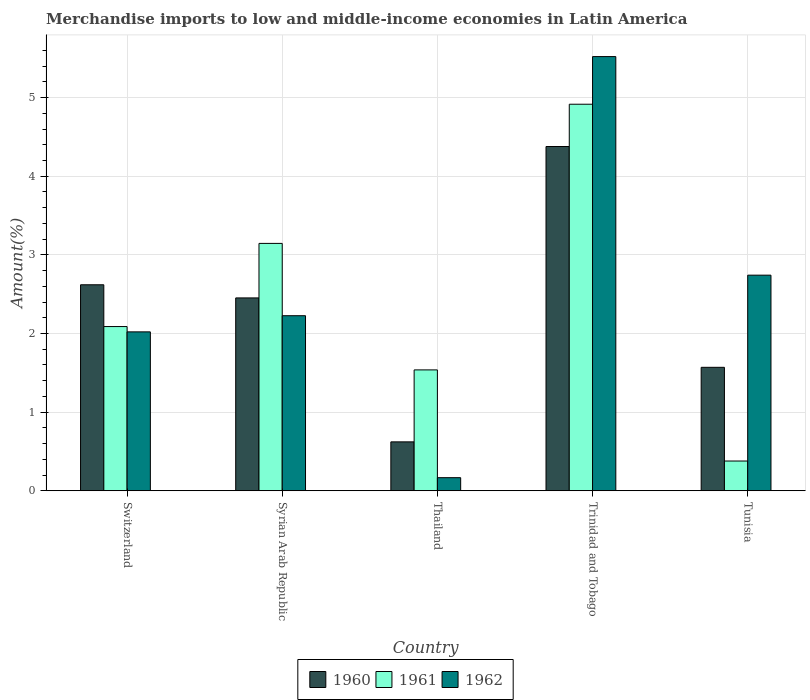How many different coloured bars are there?
Make the answer very short. 3. How many groups of bars are there?
Ensure brevity in your answer.  5. Are the number of bars on each tick of the X-axis equal?
Make the answer very short. Yes. What is the label of the 5th group of bars from the left?
Give a very brief answer. Tunisia. In how many cases, is the number of bars for a given country not equal to the number of legend labels?
Keep it short and to the point. 0. What is the percentage of amount earned from merchandise imports in 1960 in Tunisia?
Ensure brevity in your answer.  1.57. Across all countries, what is the maximum percentage of amount earned from merchandise imports in 1961?
Your response must be concise. 4.92. Across all countries, what is the minimum percentage of amount earned from merchandise imports in 1960?
Give a very brief answer. 0.62. In which country was the percentage of amount earned from merchandise imports in 1962 maximum?
Provide a short and direct response. Trinidad and Tobago. In which country was the percentage of amount earned from merchandise imports in 1961 minimum?
Your answer should be very brief. Tunisia. What is the total percentage of amount earned from merchandise imports in 1960 in the graph?
Offer a very short reply. 11.64. What is the difference between the percentage of amount earned from merchandise imports in 1962 in Syrian Arab Republic and that in Tunisia?
Your answer should be compact. -0.52. What is the difference between the percentage of amount earned from merchandise imports in 1961 in Tunisia and the percentage of amount earned from merchandise imports in 1962 in Thailand?
Give a very brief answer. 0.21. What is the average percentage of amount earned from merchandise imports in 1962 per country?
Offer a very short reply. 2.54. What is the difference between the percentage of amount earned from merchandise imports of/in 1960 and percentage of amount earned from merchandise imports of/in 1961 in Thailand?
Give a very brief answer. -0.92. What is the ratio of the percentage of amount earned from merchandise imports in 1961 in Thailand to that in Trinidad and Tobago?
Provide a short and direct response. 0.31. Is the difference between the percentage of amount earned from merchandise imports in 1960 in Trinidad and Tobago and Tunisia greater than the difference between the percentage of amount earned from merchandise imports in 1961 in Trinidad and Tobago and Tunisia?
Your answer should be very brief. No. What is the difference between the highest and the second highest percentage of amount earned from merchandise imports in 1961?
Give a very brief answer. -1.06. What is the difference between the highest and the lowest percentage of amount earned from merchandise imports in 1960?
Provide a succinct answer. 3.76. Is the sum of the percentage of amount earned from merchandise imports in 1960 in Thailand and Tunisia greater than the maximum percentage of amount earned from merchandise imports in 1962 across all countries?
Offer a very short reply. No. Is it the case that in every country, the sum of the percentage of amount earned from merchandise imports in 1961 and percentage of amount earned from merchandise imports in 1960 is greater than the percentage of amount earned from merchandise imports in 1962?
Your response must be concise. No. What is the difference between two consecutive major ticks on the Y-axis?
Provide a short and direct response. 1. Are the values on the major ticks of Y-axis written in scientific E-notation?
Offer a very short reply. No. Does the graph contain any zero values?
Provide a short and direct response. No. Does the graph contain grids?
Offer a terse response. Yes. How are the legend labels stacked?
Keep it short and to the point. Horizontal. What is the title of the graph?
Keep it short and to the point. Merchandise imports to low and middle-income economies in Latin America. What is the label or title of the X-axis?
Provide a short and direct response. Country. What is the label or title of the Y-axis?
Provide a short and direct response. Amount(%). What is the Amount(%) of 1960 in Switzerland?
Make the answer very short. 2.62. What is the Amount(%) of 1961 in Switzerland?
Offer a very short reply. 2.09. What is the Amount(%) of 1962 in Switzerland?
Make the answer very short. 2.02. What is the Amount(%) in 1960 in Syrian Arab Republic?
Provide a succinct answer. 2.45. What is the Amount(%) of 1961 in Syrian Arab Republic?
Your answer should be compact. 3.15. What is the Amount(%) of 1962 in Syrian Arab Republic?
Ensure brevity in your answer.  2.23. What is the Amount(%) of 1960 in Thailand?
Your answer should be very brief. 0.62. What is the Amount(%) in 1961 in Thailand?
Your answer should be very brief. 1.54. What is the Amount(%) of 1962 in Thailand?
Keep it short and to the point. 0.17. What is the Amount(%) of 1960 in Trinidad and Tobago?
Provide a short and direct response. 4.38. What is the Amount(%) of 1961 in Trinidad and Tobago?
Offer a very short reply. 4.92. What is the Amount(%) in 1962 in Trinidad and Tobago?
Provide a short and direct response. 5.52. What is the Amount(%) of 1960 in Tunisia?
Your answer should be very brief. 1.57. What is the Amount(%) in 1961 in Tunisia?
Keep it short and to the point. 0.38. What is the Amount(%) in 1962 in Tunisia?
Your answer should be compact. 2.74. Across all countries, what is the maximum Amount(%) of 1960?
Your answer should be compact. 4.38. Across all countries, what is the maximum Amount(%) in 1961?
Offer a terse response. 4.92. Across all countries, what is the maximum Amount(%) of 1962?
Your answer should be very brief. 5.52. Across all countries, what is the minimum Amount(%) in 1960?
Ensure brevity in your answer.  0.62. Across all countries, what is the minimum Amount(%) of 1961?
Provide a succinct answer. 0.38. Across all countries, what is the minimum Amount(%) of 1962?
Your answer should be very brief. 0.17. What is the total Amount(%) in 1960 in the graph?
Provide a succinct answer. 11.64. What is the total Amount(%) of 1961 in the graph?
Give a very brief answer. 12.06. What is the total Amount(%) in 1962 in the graph?
Offer a terse response. 12.68. What is the difference between the Amount(%) in 1960 in Switzerland and that in Syrian Arab Republic?
Make the answer very short. 0.17. What is the difference between the Amount(%) of 1961 in Switzerland and that in Syrian Arab Republic?
Offer a very short reply. -1.06. What is the difference between the Amount(%) of 1962 in Switzerland and that in Syrian Arab Republic?
Offer a terse response. -0.21. What is the difference between the Amount(%) of 1960 in Switzerland and that in Thailand?
Make the answer very short. 2. What is the difference between the Amount(%) in 1961 in Switzerland and that in Thailand?
Provide a succinct answer. 0.55. What is the difference between the Amount(%) in 1962 in Switzerland and that in Thailand?
Your response must be concise. 1.85. What is the difference between the Amount(%) in 1960 in Switzerland and that in Trinidad and Tobago?
Give a very brief answer. -1.76. What is the difference between the Amount(%) of 1961 in Switzerland and that in Trinidad and Tobago?
Keep it short and to the point. -2.83. What is the difference between the Amount(%) in 1962 in Switzerland and that in Trinidad and Tobago?
Provide a succinct answer. -3.5. What is the difference between the Amount(%) of 1960 in Switzerland and that in Tunisia?
Your answer should be compact. 1.05. What is the difference between the Amount(%) of 1961 in Switzerland and that in Tunisia?
Make the answer very short. 1.71. What is the difference between the Amount(%) of 1962 in Switzerland and that in Tunisia?
Offer a terse response. -0.72. What is the difference between the Amount(%) of 1960 in Syrian Arab Republic and that in Thailand?
Offer a terse response. 1.83. What is the difference between the Amount(%) in 1961 in Syrian Arab Republic and that in Thailand?
Your answer should be very brief. 1.61. What is the difference between the Amount(%) in 1962 in Syrian Arab Republic and that in Thailand?
Give a very brief answer. 2.06. What is the difference between the Amount(%) in 1960 in Syrian Arab Republic and that in Trinidad and Tobago?
Provide a succinct answer. -1.93. What is the difference between the Amount(%) of 1961 in Syrian Arab Republic and that in Trinidad and Tobago?
Your answer should be compact. -1.77. What is the difference between the Amount(%) in 1962 in Syrian Arab Republic and that in Trinidad and Tobago?
Your answer should be compact. -3.29. What is the difference between the Amount(%) of 1960 in Syrian Arab Republic and that in Tunisia?
Your answer should be compact. 0.88. What is the difference between the Amount(%) of 1961 in Syrian Arab Republic and that in Tunisia?
Offer a very short reply. 2.77. What is the difference between the Amount(%) of 1962 in Syrian Arab Republic and that in Tunisia?
Provide a short and direct response. -0.52. What is the difference between the Amount(%) of 1960 in Thailand and that in Trinidad and Tobago?
Make the answer very short. -3.76. What is the difference between the Amount(%) in 1961 in Thailand and that in Trinidad and Tobago?
Ensure brevity in your answer.  -3.38. What is the difference between the Amount(%) of 1962 in Thailand and that in Trinidad and Tobago?
Offer a terse response. -5.35. What is the difference between the Amount(%) of 1960 in Thailand and that in Tunisia?
Your response must be concise. -0.95. What is the difference between the Amount(%) in 1961 in Thailand and that in Tunisia?
Make the answer very short. 1.16. What is the difference between the Amount(%) of 1962 in Thailand and that in Tunisia?
Your response must be concise. -2.58. What is the difference between the Amount(%) in 1960 in Trinidad and Tobago and that in Tunisia?
Your answer should be very brief. 2.81. What is the difference between the Amount(%) in 1961 in Trinidad and Tobago and that in Tunisia?
Your response must be concise. 4.54. What is the difference between the Amount(%) in 1962 in Trinidad and Tobago and that in Tunisia?
Provide a short and direct response. 2.78. What is the difference between the Amount(%) of 1960 in Switzerland and the Amount(%) of 1961 in Syrian Arab Republic?
Your response must be concise. -0.53. What is the difference between the Amount(%) of 1960 in Switzerland and the Amount(%) of 1962 in Syrian Arab Republic?
Make the answer very short. 0.39. What is the difference between the Amount(%) in 1961 in Switzerland and the Amount(%) in 1962 in Syrian Arab Republic?
Offer a terse response. -0.14. What is the difference between the Amount(%) of 1960 in Switzerland and the Amount(%) of 1961 in Thailand?
Give a very brief answer. 1.08. What is the difference between the Amount(%) of 1960 in Switzerland and the Amount(%) of 1962 in Thailand?
Your response must be concise. 2.45. What is the difference between the Amount(%) of 1961 in Switzerland and the Amount(%) of 1962 in Thailand?
Make the answer very short. 1.92. What is the difference between the Amount(%) in 1960 in Switzerland and the Amount(%) in 1961 in Trinidad and Tobago?
Ensure brevity in your answer.  -2.3. What is the difference between the Amount(%) of 1960 in Switzerland and the Amount(%) of 1962 in Trinidad and Tobago?
Provide a succinct answer. -2.9. What is the difference between the Amount(%) of 1961 in Switzerland and the Amount(%) of 1962 in Trinidad and Tobago?
Make the answer very short. -3.43. What is the difference between the Amount(%) in 1960 in Switzerland and the Amount(%) in 1961 in Tunisia?
Keep it short and to the point. 2.24. What is the difference between the Amount(%) of 1960 in Switzerland and the Amount(%) of 1962 in Tunisia?
Your answer should be compact. -0.12. What is the difference between the Amount(%) of 1961 in Switzerland and the Amount(%) of 1962 in Tunisia?
Ensure brevity in your answer.  -0.65. What is the difference between the Amount(%) of 1960 in Syrian Arab Republic and the Amount(%) of 1961 in Thailand?
Keep it short and to the point. 0.92. What is the difference between the Amount(%) in 1960 in Syrian Arab Republic and the Amount(%) in 1962 in Thailand?
Keep it short and to the point. 2.29. What is the difference between the Amount(%) in 1961 in Syrian Arab Republic and the Amount(%) in 1962 in Thailand?
Provide a succinct answer. 2.98. What is the difference between the Amount(%) of 1960 in Syrian Arab Republic and the Amount(%) of 1961 in Trinidad and Tobago?
Provide a short and direct response. -2.46. What is the difference between the Amount(%) in 1960 in Syrian Arab Republic and the Amount(%) in 1962 in Trinidad and Tobago?
Give a very brief answer. -3.07. What is the difference between the Amount(%) of 1961 in Syrian Arab Republic and the Amount(%) of 1962 in Trinidad and Tobago?
Make the answer very short. -2.38. What is the difference between the Amount(%) of 1960 in Syrian Arab Republic and the Amount(%) of 1961 in Tunisia?
Offer a terse response. 2.07. What is the difference between the Amount(%) in 1960 in Syrian Arab Republic and the Amount(%) in 1962 in Tunisia?
Ensure brevity in your answer.  -0.29. What is the difference between the Amount(%) in 1961 in Syrian Arab Republic and the Amount(%) in 1962 in Tunisia?
Make the answer very short. 0.4. What is the difference between the Amount(%) of 1960 in Thailand and the Amount(%) of 1961 in Trinidad and Tobago?
Your answer should be very brief. -4.29. What is the difference between the Amount(%) in 1960 in Thailand and the Amount(%) in 1962 in Trinidad and Tobago?
Make the answer very short. -4.9. What is the difference between the Amount(%) of 1961 in Thailand and the Amount(%) of 1962 in Trinidad and Tobago?
Your response must be concise. -3.98. What is the difference between the Amount(%) of 1960 in Thailand and the Amount(%) of 1961 in Tunisia?
Offer a terse response. 0.24. What is the difference between the Amount(%) of 1960 in Thailand and the Amount(%) of 1962 in Tunisia?
Offer a very short reply. -2.12. What is the difference between the Amount(%) in 1961 in Thailand and the Amount(%) in 1962 in Tunisia?
Keep it short and to the point. -1.2. What is the difference between the Amount(%) in 1960 in Trinidad and Tobago and the Amount(%) in 1961 in Tunisia?
Provide a short and direct response. 4. What is the difference between the Amount(%) in 1960 in Trinidad and Tobago and the Amount(%) in 1962 in Tunisia?
Your response must be concise. 1.64. What is the difference between the Amount(%) of 1961 in Trinidad and Tobago and the Amount(%) of 1962 in Tunisia?
Provide a short and direct response. 2.17. What is the average Amount(%) in 1960 per country?
Your answer should be compact. 2.33. What is the average Amount(%) of 1961 per country?
Your response must be concise. 2.41. What is the average Amount(%) in 1962 per country?
Offer a very short reply. 2.54. What is the difference between the Amount(%) in 1960 and Amount(%) in 1961 in Switzerland?
Ensure brevity in your answer.  0.53. What is the difference between the Amount(%) in 1960 and Amount(%) in 1962 in Switzerland?
Provide a succinct answer. 0.6. What is the difference between the Amount(%) in 1961 and Amount(%) in 1962 in Switzerland?
Keep it short and to the point. 0.07. What is the difference between the Amount(%) of 1960 and Amount(%) of 1961 in Syrian Arab Republic?
Offer a very short reply. -0.69. What is the difference between the Amount(%) in 1960 and Amount(%) in 1962 in Syrian Arab Republic?
Offer a terse response. 0.23. What is the difference between the Amount(%) of 1961 and Amount(%) of 1962 in Syrian Arab Republic?
Give a very brief answer. 0.92. What is the difference between the Amount(%) in 1960 and Amount(%) in 1961 in Thailand?
Your answer should be compact. -0.92. What is the difference between the Amount(%) in 1960 and Amount(%) in 1962 in Thailand?
Provide a short and direct response. 0.46. What is the difference between the Amount(%) in 1961 and Amount(%) in 1962 in Thailand?
Provide a short and direct response. 1.37. What is the difference between the Amount(%) in 1960 and Amount(%) in 1961 in Trinidad and Tobago?
Ensure brevity in your answer.  -0.54. What is the difference between the Amount(%) in 1960 and Amount(%) in 1962 in Trinidad and Tobago?
Provide a succinct answer. -1.14. What is the difference between the Amount(%) of 1961 and Amount(%) of 1962 in Trinidad and Tobago?
Give a very brief answer. -0.61. What is the difference between the Amount(%) in 1960 and Amount(%) in 1961 in Tunisia?
Provide a succinct answer. 1.19. What is the difference between the Amount(%) of 1960 and Amount(%) of 1962 in Tunisia?
Offer a very short reply. -1.17. What is the difference between the Amount(%) of 1961 and Amount(%) of 1962 in Tunisia?
Ensure brevity in your answer.  -2.36. What is the ratio of the Amount(%) of 1960 in Switzerland to that in Syrian Arab Republic?
Keep it short and to the point. 1.07. What is the ratio of the Amount(%) of 1961 in Switzerland to that in Syrian Arab Republic?
Your answer should be compact. 0.66. What is the ratio of the Amount(%) in 1962 in Switzerland to that in Syrian Arab Republic?
Give a very brief answer. 0.91. What is the ratio of the Amount(%) of 1960 in Switzerland to that in Thailand?
Provide a short and direct response. 4.21. What is the ratio of the Amount(%) of 1961 in Switzerland to that in Thailand?
Your answer should be compact. 1.36. What is the ratio of the Amount(%) in 1962 in Switzerland to that in Thailand?
Your response must be concise. 12.13. What is the ratio of the Amount(%) in 1960 in Switzerland to that in Trinidad and Tobago?
Offer a terse response. 0.6. What is the ratio of the Amount(%) of 1961 in Switzerland to that in Trinidad and Tobago?
Give a very brief answer. 0.42. What is the ratio of the Amount(%) of 1962 in Switzerland to that in Trinidad and Tobago?
Provide a succinct answer. 0.37. What is the ratio of the Amount(%) in 1960 in Switzerland to that in Tunisia?
Your answer should be compact. 1.67. What is the ratio of the Amount(%) in 1961 in Switzerland to that in Tunisia?
Offer a terse response. 5.52. What is the ratio of the Amount(%) of 1962 in Switzerland to that in Tunisia?
Ensure brevity in your answer.  0.74. What is the ratio of the Amount(%) in 1960 in Syrian Arab Republic to that in Thailand?
Your answer should be compact. 3.94. What is the ratio of the Amount(%) of 1961 in Syrian Arab Republic to that in Thailand?
Your response must be concise. 2.05. What is the ratio of the Amount(%) in 1962 in Syrian Arab Republic to that in Thailand?
Your answer should be very brief. 13.36. What is the ratio of the Amount(%) in 1960 in Syrian Arab Republic to that in Trinidad and Tobago?
Make the answer very short. 0.56. What is the ratio of the Amount(%) in 1961 in Syrian Arab Republic to that in Trinidad and Tobago?
Ensure brevity in your answer.  0.64. What is the ratio of the Amount(%) of 1962 in Syrian Arab Republic to that in Trinidad and Tobago?
Your response must be concise. 0.4. What is the ratio of the Amount(%) of 1960 in Syrian Arab Republic to that in Tunisia?
Ensure brevity in your answer.  1.56. What is the ratio of the Amount(%) of 1961 in Syrian Arab Republic to that in Tunisia?
Give a very brief answer. 8.31. What is the ratio of the Amount(%) in 1962 in Syrian Arab Republic to that in Tunisia?
Give a very brief answer. 0.81. What is the ratio of the Amount(%) of 1960 in Thailand to that in Trinidad and Tobago?
Provide a succinct answer. 0.14. What is the ratio of the Amount(%) of 1961 in Thailand to that in Trinidad and Tobago?
Provide a succinct answer. 0.31. What is the ratio of the Amount(%) in 1962 in Thailand to that in Trinidad and Tobago?
Your response must be concise. 0.03. What is the ratio of the Amount(%) in 1960 in Thailand to that in Tunisia?
Your answer should be very brief. 0.4. What is the ratio of the Amount(%) in 1961 in Thailand to that in Tunisia?
Make the answer very short. 4.06. What is the ratio of the Amount(%) in 1962 in Thailand to that in Tunisia?
Your answer should be very brief. 0.06. What is the ratio of the Amount(%) in 1960 in Trinidad and Tobago to that in Tunisia?
Your response must be concise. 2.79. What is the ratio of the Amount(%) in 1961 in Trinidad and Tobago to that in Tunisia?
Ensure brevity in your answer.  12.99. What is the ratio of the Amount(%) in 1962 in Trinidad and Tobago to that in Tunisia?
Your answer should be compact. 2.01. What is the difference between the highest and the second highest Amount(%) of 1960?
Make the answer very short. 1.76. What is the difference between the highest and the second highest Amount(%) in 1961?
Ensure brevity in your answer.  1.77. What is the difference between the highest and the second highest Amount(%) of 1962?
Offer a very short reply. 2.78. What is the difference between the highest and the lowest Amount(%) in 1960?
Provide a succinct answer. 3.76. What is the difference between the highest and the lowest Amount(%) in 1961?
Your response must be concise. 4.54. What is the difference between the highest and the lowest Amount(%) of 1962?
Your response must be concise. 5.35. 